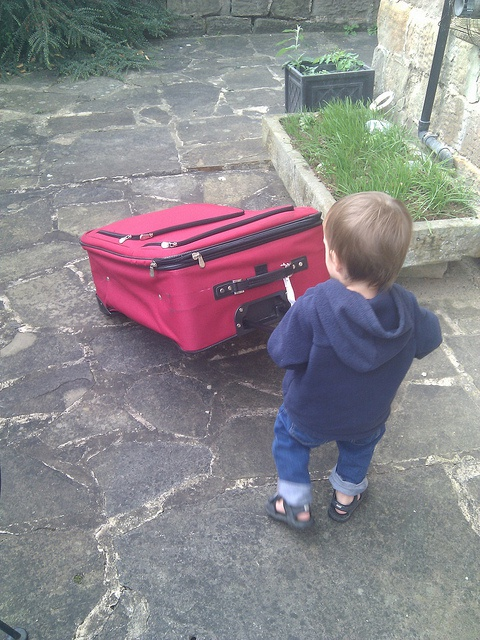Describe the objects in this image and their specific colors. I can see people in purple, gray, darkblue, and darkgray tones, suitcase in purple, violet, and brown tones, and potted plant in purple, gray, darkgray, and lightgreen tones in this image. 